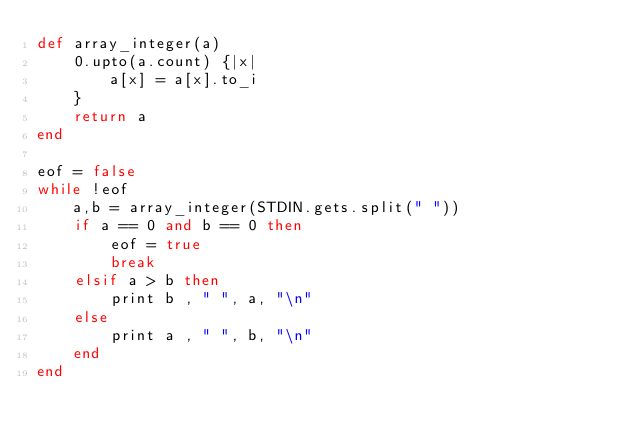<code> <loc_0><loc_0><loc_500><loc_500><_Ruby_>def array_integer(a)
	0.upto(a.count) {|x|
		a[x] = a[x].to_i
	}
	return a
end

eof = false
while !eof
	a,b = array_integer(STDIN.gets.split(" "))
	if a == 0 and b == 0 then
		eof = true
		break
	elsif a > b then
		print b , " ", a, "\n"
	else
		print a , " ", b, "\n"
	end
end

</code> 